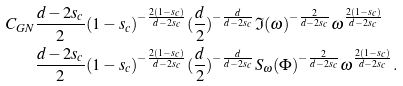Convert formula to latex. <formula><loc_0><loc_0><loc_500><loc_500>C _ { G N } & \frac { d - 2 s _ { c } } 2 ( 1 - s _ { c } ) ^ { - \frac { 2 ( 1 - s _ { c } ) } { d - 2 s _ { c } } } ( \frac { d } 2 ) ^ { - \frac { d } { d - 2 s _ { c } } } \mathfrak { I } ( \omega ) ^ { - \frac { 2 } { d - 2 s _ { c } } } \omega ^ { \frac { 2 ( 1 - s _ { c } ) } { d - 2 s _ { c } } } \\ & \frac { d - 2 s _ { c } } 2 ( 1 - s _ { c } ) ^ { - \frac { 2 ( 1 - s _ { c } ) } { d - 2 s _ { c } } } ( \frac { d } 2 ) ^ { - \frac { d } { d - 2 s _ { c } } } S _ { \omega } ( \Phi ) ^ { - \frac { 2 } { d - 2 s _ { c } } } \omega ^ { \frac { 2 ( 1 - s _ { c } ) } { d - 2 s _ { c } } } .</formula> 